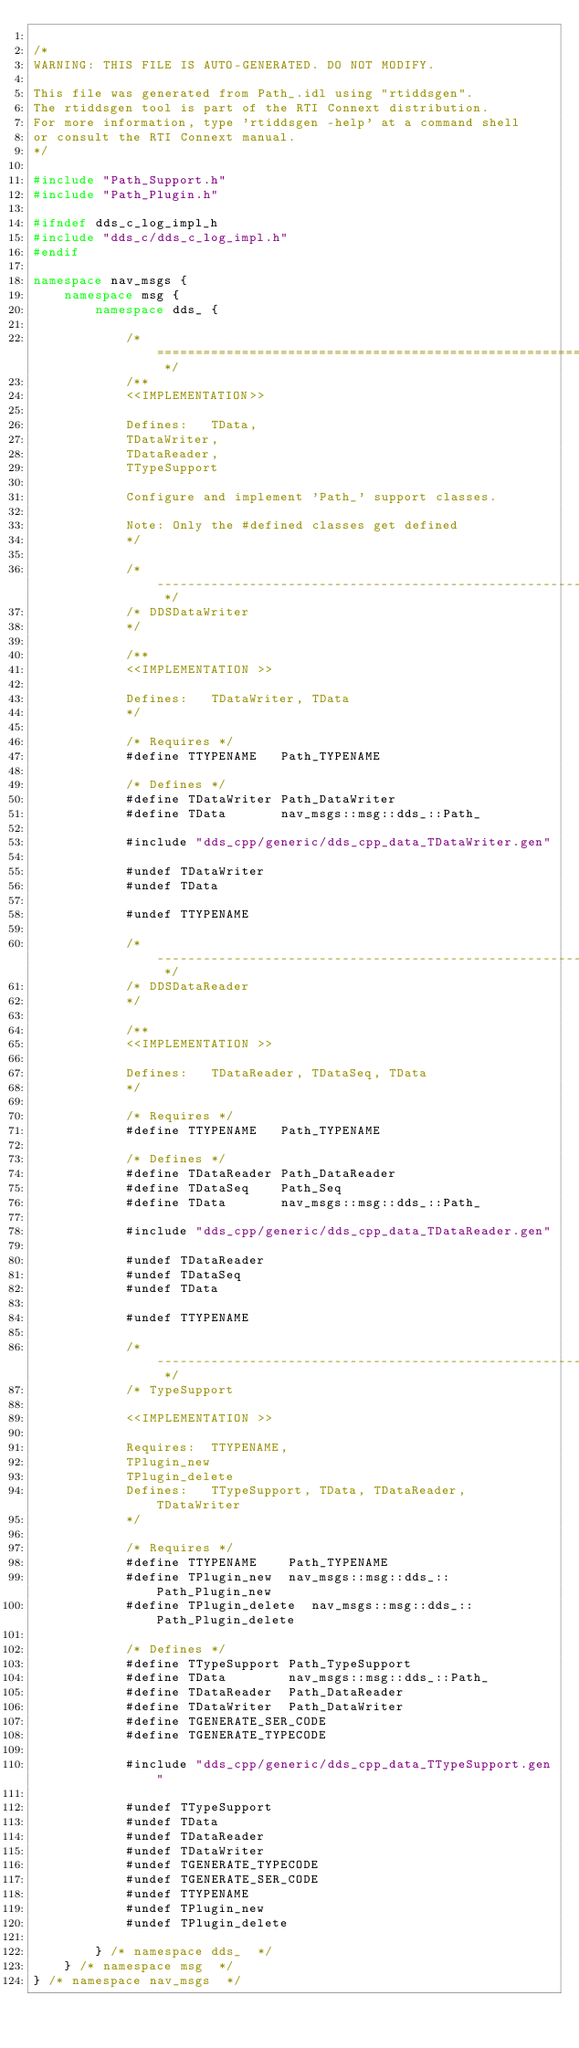<code> <loc_0><loc_0><loc_500><loc_500><_C++_>
/*
WARNING: THIS FILE IS AUTO-GENERATED. DO NOT MODIFY.

This file was generated from Path_.idl using "rtiddsgen".
The rtiddsgen tool is part of the RTI Connext distribution.
For more information, type 'rtiddsgen -help' at a command shell
or consult the RTI Connext manual.
*/

#include "Path_Support.h"
#include "Path_Plugin.h"

#ifndef dds_c_log_impl_h              
#include "dds_c/dds_c_log_impl.h"                                
#endif        

namespace nav_msgs {
    namespace msg {
        namespace dds_ {

            /* ========================================================================= */
            /**
            <<IMPLEMENTATION>>

            Defines:   TData,
            TDataWriter,
            TDataReader,
            TTypeSupport

            Configure and implement 'Path_' support classes.

            Note: Only the #defined classes get defined
            */

            /* ----------------------------------------------------------------- */
            /* DDSDataWriter
            */

            /**
            <<IMPLEMENTATION >>

            Defines:   TDataWriter, TData
            */

            /* Requires */
            #define TTYPENAME   Path_TYPENAME

            /* Defines */
            #define TDataWriter Path_DataWriter
            #define TData       nav_msgs::msg::dds_::Path_

            #include "dds_cpp/generic/dds_cpp_data_TDataWriter.gen"

            #undef TDataWriter
            #undef TData

            #undef TTYPENAME

            /* ----------------------------------------------------------------- */
            /* DDSDataReader
            */

            /**
            <<IMPLEMENTATION >>

            Defines:   TDataReader, TDataSeq, TData
            */

            /* Requires */
            #define TTYPENAME   Path_TYPENAME

            /* Defines */
            #define TDataReader Path_DataReader
            #define TDataSeq    Path_Seq
            #define TData       nav_msgs::msg::dds_::Path_

            #include "dds_cpp/generic/dds_cpp_data_TDataReader.gen"

            #undef TDataReader
            #undef TDataSeq
            #undef TData

            #undef TTYPENAME

            /* ----------------------------------------------------------------- */
            /* TypeSupport

            <<IMPLEMENTATION >>

            Requires:  TTYPENAME,
            TPlugin_new
            TPlugin_delete
            Defines:   TTypeSupport, TData, TDataReader, TDataWriter
            */

            /* Requires */
            #define TTYPENAME    Path_TYPENAME
            #define TPlugin_new  nav_msgs::msg::dds_::Path_Plugin_new
            #define TPlugin_delete  nav_msgs::msg::dds_::Path_Plugin_delete

            /* Defines */
            #define TTypeSupport Path_TypeSupport
            #define TData        nav_msgs::msg::dds_::Path_
            #define TDataReader  Path_DataReader
            #define TDataWriter  Path_DataWriter
            #define TGENERATE_SER_CODE
            #define TGENERATE_TYPECODE

            #include "dds_cpp/generic/dds_cpp_data_TTypeSupport.gen"

            #undef TTypeSupport
            #undef TData
            #undef TDataReader
            #undef TDataWriter
            #undef TGENERATE_TYPECODE
            #undef TGENERATE_SER_CODE
            #undef TTYPENAME
            #undef TPlugin_new
            #undef TPlugin_delete

        } /* namespace dds_  */
    } /* namespace msg  */
} /* namespace nav_msgs  */

</code> 